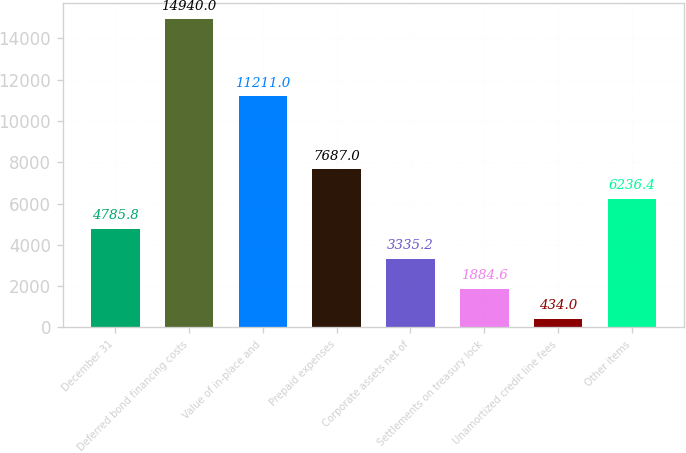Convert chart to OTSL. <chart><loc_0><loc_0><loc_500><loc_500><bar_chart><fcel>December 31<fcel>Deferred bond financing costs<fcel>Value of in-place and<fcel>Prepaid expenses<fcel>Corporate assets net of<fcel>Settlements on treasury lock<fcel>Unamortized credit line fees<fcel>Other items<nl><fcel>4785.8<fcel>14940<fcel>11211<fcel>7687<fcel>3335.2<fcel>1884.6<fcel>434<fcel>6236.4<nl></chart> 